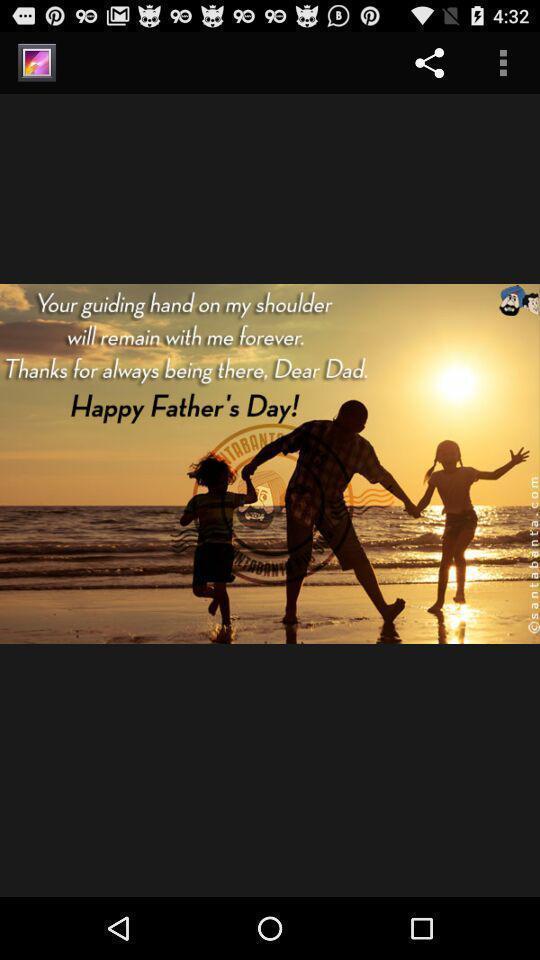Describe the visual elements of this screenshot. Screen displaying image with share option. 